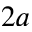Convert formula to latex. <formula><loc_0><loc_0><loc_500><loc_500>2 a</formula> 